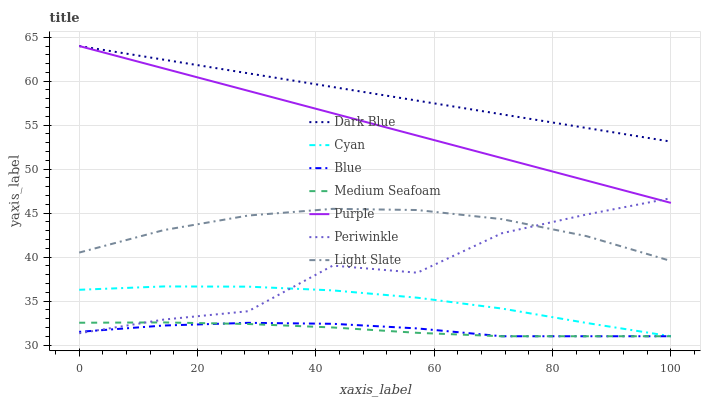Does Medium Seafoam have the minimum area under the curve?
Answer yes or no. Yes. Does Dark Blue have the maximum area under the curve?
Answer yes or no. Yes. Does Purple have the minimum area under the curve?
Answer yes or no. No. Does Purple have the maximum area under the curve?
Answer yes or no. No. Is Dark Blue the smoothest?
Answer yes or no. Yes. Is Periwinkle the roughest?
Answer yes or no. Yes. Is Purple the smoothest?
Answer yes or no. No. Is Purple the roughest?
Answer yes or no. No. Does Blue have the lowest value?
Answer yes or no. Yes. Does Purple have the lowest value?
Answer yes or no. No. Does Dark Blue have the highest value?
Answer yes or no. Yes. Does Light Slate have the highest value?
Answer yes or no. No. Is Blue less than Light Slate?
Answer yes or no. Yes. Is Dark Blue greater than Light Slate?
Answer yes or no. Yes. Does Blue intersect Periwinkle?
Answer yes or no. Yes. Is Blue less than Periwinkle?
Answer yes or no. No. Is Blue greater than Periwinkle?
Answer yes or no. No. Does Blue intersect Light Slate?
Answer yes or no. No. 